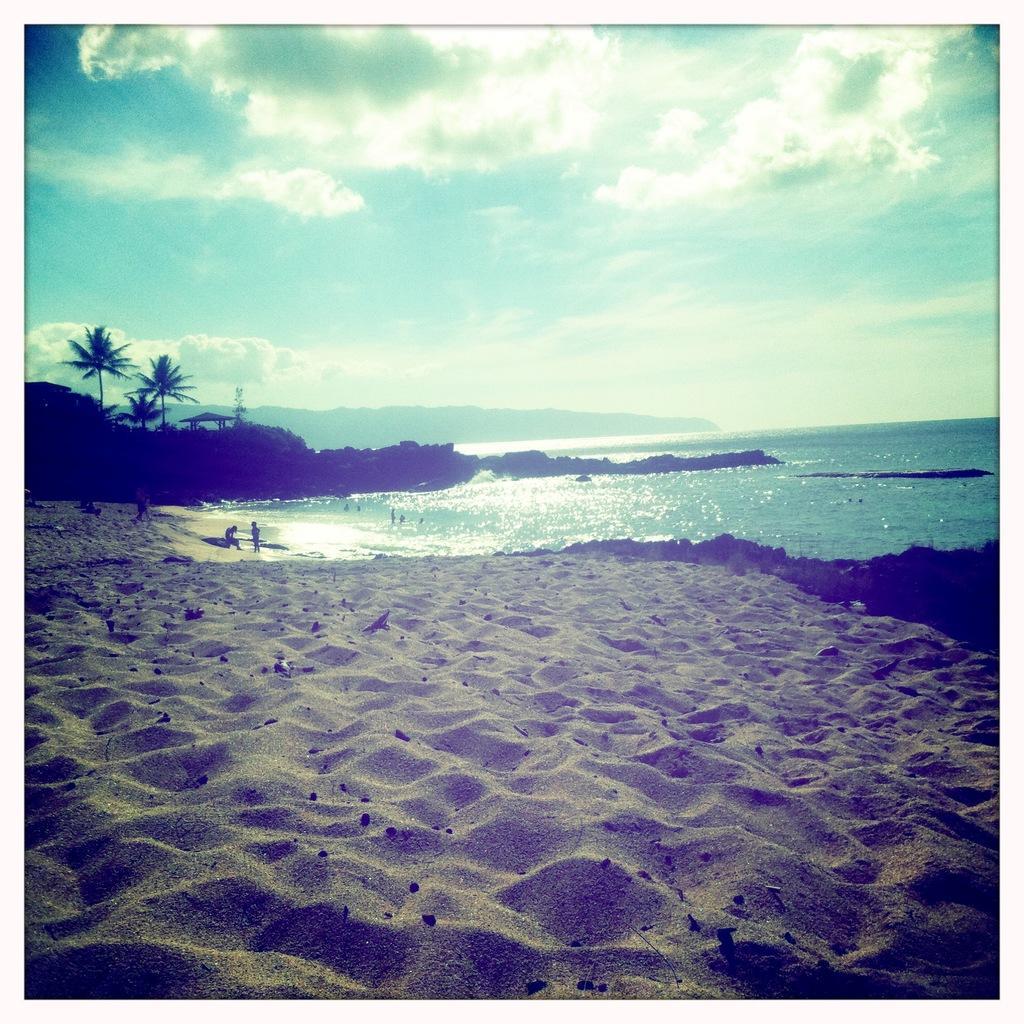In one or two sentences, can you explain what this image depicts? In this picture we can see sand. There are people and we can see water. In the background of the image we can see trees, shed, hills and sky with clouds. 